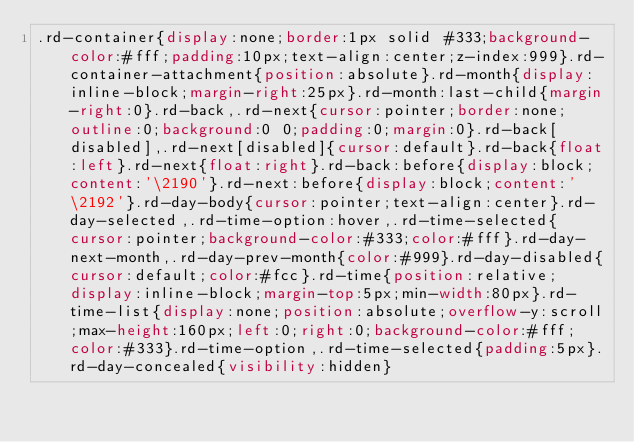<code> <loc_0><loc_0><loc_500><loc_500><_CSS_>.rd-container{display:none;border:1px solid #333;background-color:#fff;padding:10px;text-align:center;z-index:999}.rd-container-attachment{position:absolute}.rd-month{display:inline-block;margin-right:25px}.rd-month:last-child{margin-right:0}.rd-back,.rd-next{cursor:pointer;border:none;outline:0;background:0 0;padding:0;margin:0}.rd-back[disabled],.rd-next[disabled]{cursor:default}.rd-back{float:left}.rd-next{float:right}.rd-back:before{display:block;content:'\2190'}.rd-next:before{display:block;content:'\2192'}.rd-day-body{cursor:pointer;text-align:center}.rd-day-selected,.rd-time-option:hover,.rd-time-selected{cursor:pointer;background-color:#333;color:#fff}.rd-day-next-month,.rd-day-prev-month{color:#999}.rd-day-disabled{cursor:default;color:#fcc}.rd-time{position:relative;display:inline-block;margin-top:5px;min-width:80px}.rd-time-list{display:none;position:absolute;overflow-y:scroll;max-height:160px;left:0;right:0;background-color:#fff;color:#333}.rd-time-option,.rd-time-selected{padding:5px}.rd-day-concealed{visibility:hidden}
</code> 